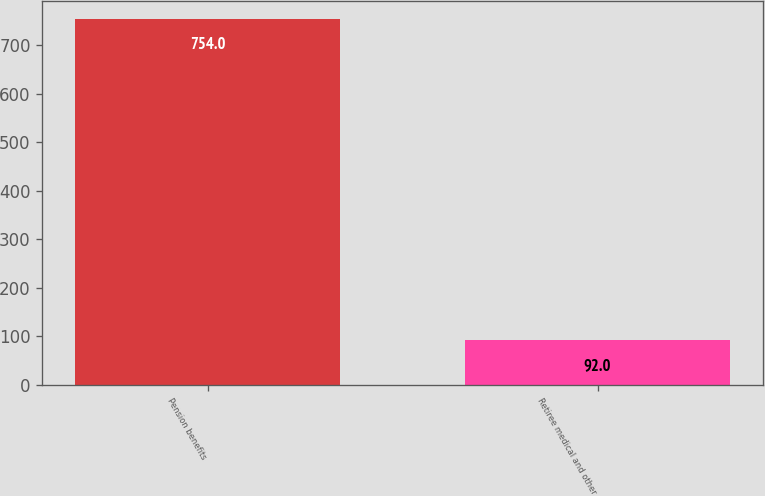Convert chart to OTSL. <chart><loc_0><loc_0><loc_500><loc_500><bar_chart><fcel>Pension benefits<fcel>Retiree medical and other<nl><fcel>754<fcel>92<nl></chart> 